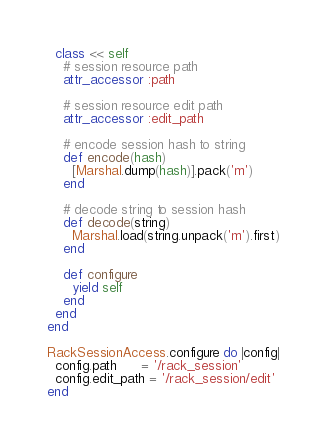Convert code to text. <code><loc_0><loc_0><loc_500><loc_500><_Ruby_>  class << self
    # session resource path
    attr_accessor :path

    # session resource edit path
    attr_accessor :edit_path

    # encode session hash to string
    def encode(hash)
      [Marshal.dump(hash)].pack('m')
    end

    # decode string to session hash
    def decode(string)
      Marshal.load(string.unpack('m').first)
    end

    def configure
      yield self
    end
  end
end

RackSessionAccess.configure do |config|
  config.path      = '/rack_session'
  config.edit_path = '/rack_session/edit'
end
</code> 